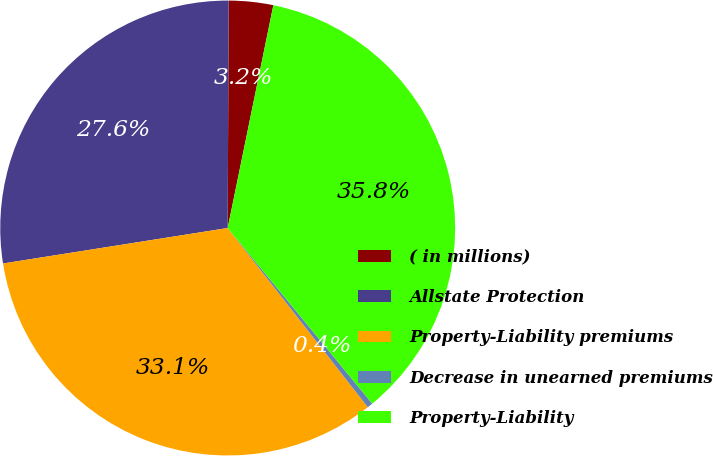Convert chart to OTSL. <chart><loc_0><loc_0><loc_500><loc_500><pie_chart><fcel>( in millions)<fcel>Allstate Protection<fcel>Property-Liability premiums<fcel>Decrease in unearned premiums<fcel>Property-Liability<nl><fcel>3.15%<fcel>27.56%<fcel>33.07%<fcel>0.4%<fcel>35.82%<nl></chart> 